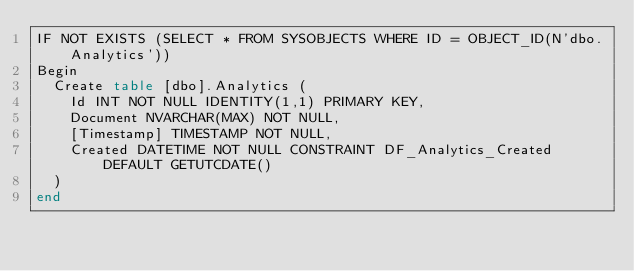Convert code to text. <code><loc_0><loc_0><loc_500><loc_500><_SQL_>IF NOT EXISTS (SELECT * FROM SYSOBJECTS WHERE ID = OBJECT_ID(N'dbo.Analytics'))
Begin
	Create table [dbo].Analytics (
		Id INT NOT NULL IDENTITY(1,1) PRIMARY KEY,
		Document NVARCHAR(MAX) NOT NULL,
		[Timestamp] TIMESTAMP NOT NULL,
		Created DATETIME NOT NULL CONSTRAINT DF_Analytics_Created DEFAULT GETUTCDATE()
	)
end</code> 